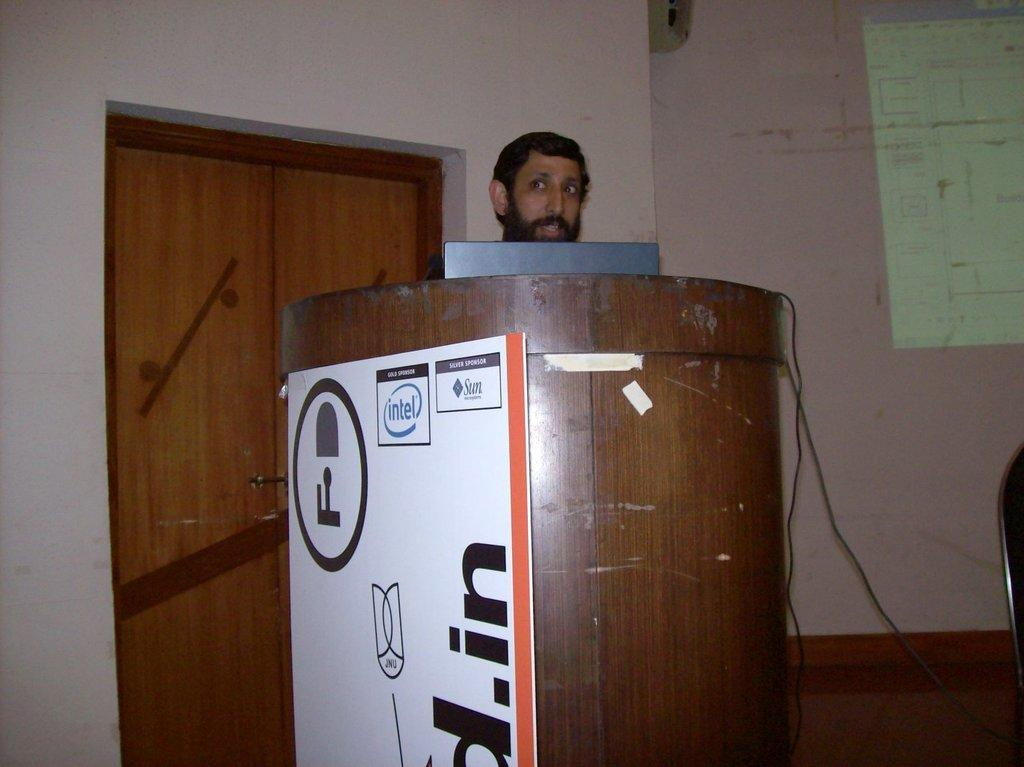<image>
Render a clear and concise summary of the photo. A man being paid by Intel and Sun stands in front of a wooden podium. 